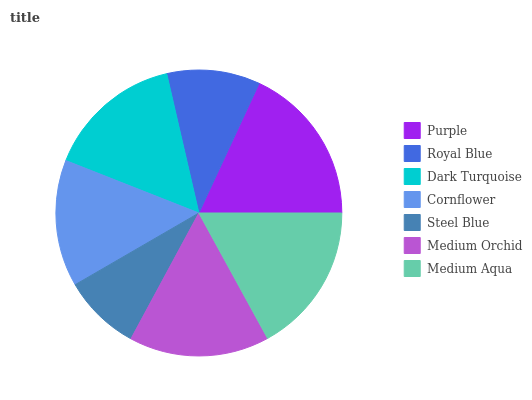Is Steel Blue the minimum?
Answer yes or no. Yes. Is Purple the maximum?
Answer yes or no. Yes. Is Royal Blue the minimum?
Answer yes or no. No. Is Royal Blue the maximum?
Answer yes or no. No. Is Purple greater than Royal Blue?
Answer yes or no. Yes. Is Royal Blue less than Purple?
Answer yes or no. Yes. Is Royal Blue greater than Purple?
Answer yes or no. No. Is Purple less than Royal Blue?
Answer yes or no. No. Is Dark Turquoise the high median?
Answer yes or no. Yes. Is Dark Turquoise the low median?
Answer yes or no. Yes. Is Royal Blue the high median?
Answer yes or no. No. Is Medium Orchid the low median?
Answer yes or no. No. 